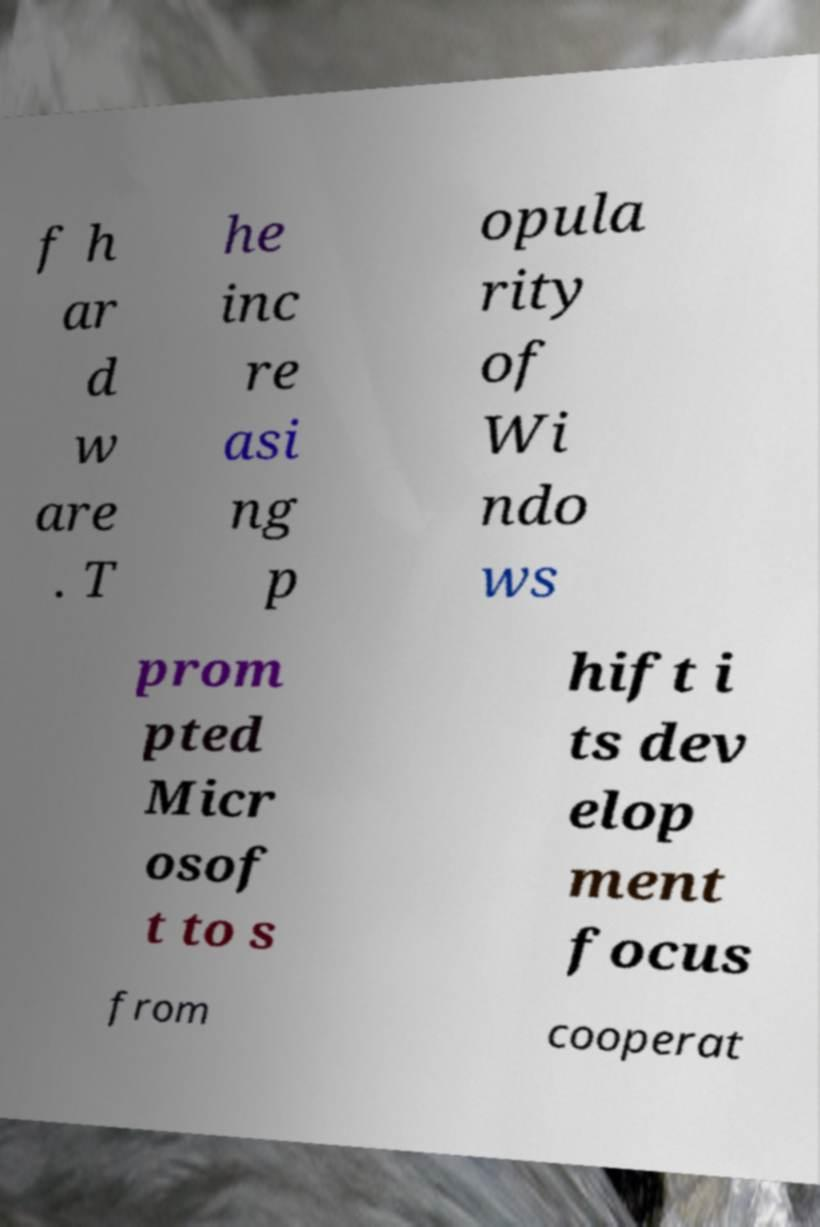What messages or text are displayed in this image? I need them in a readable, typed format. f h ar d w are . T he inc re asi ng p opula rity of Wi ndo ws prom pted Micr osof t to s hift i ts dev elop ment focus from cooperat 